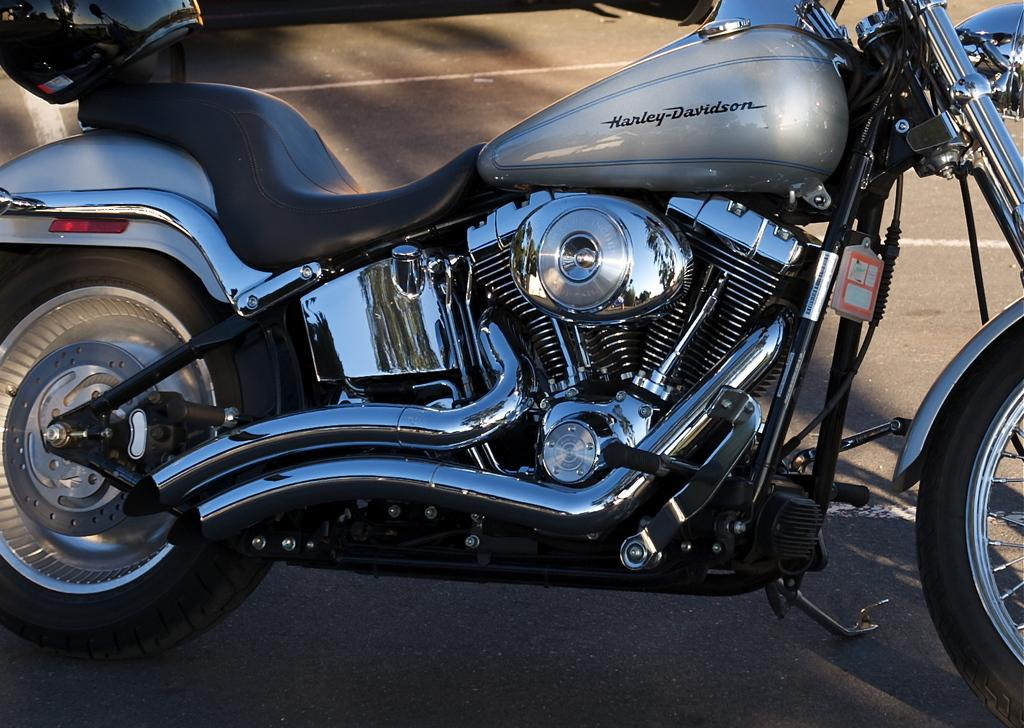What type of vehicle is in the image? There is a Harley Davidson bike in the image. What safety accessory is placed on the bike? A helmet is placed on the bike. What type of milk is being poured into the cap in the image? There is no milk or cap present in the image; it only features a Harley Davidson bike and a helmet. 